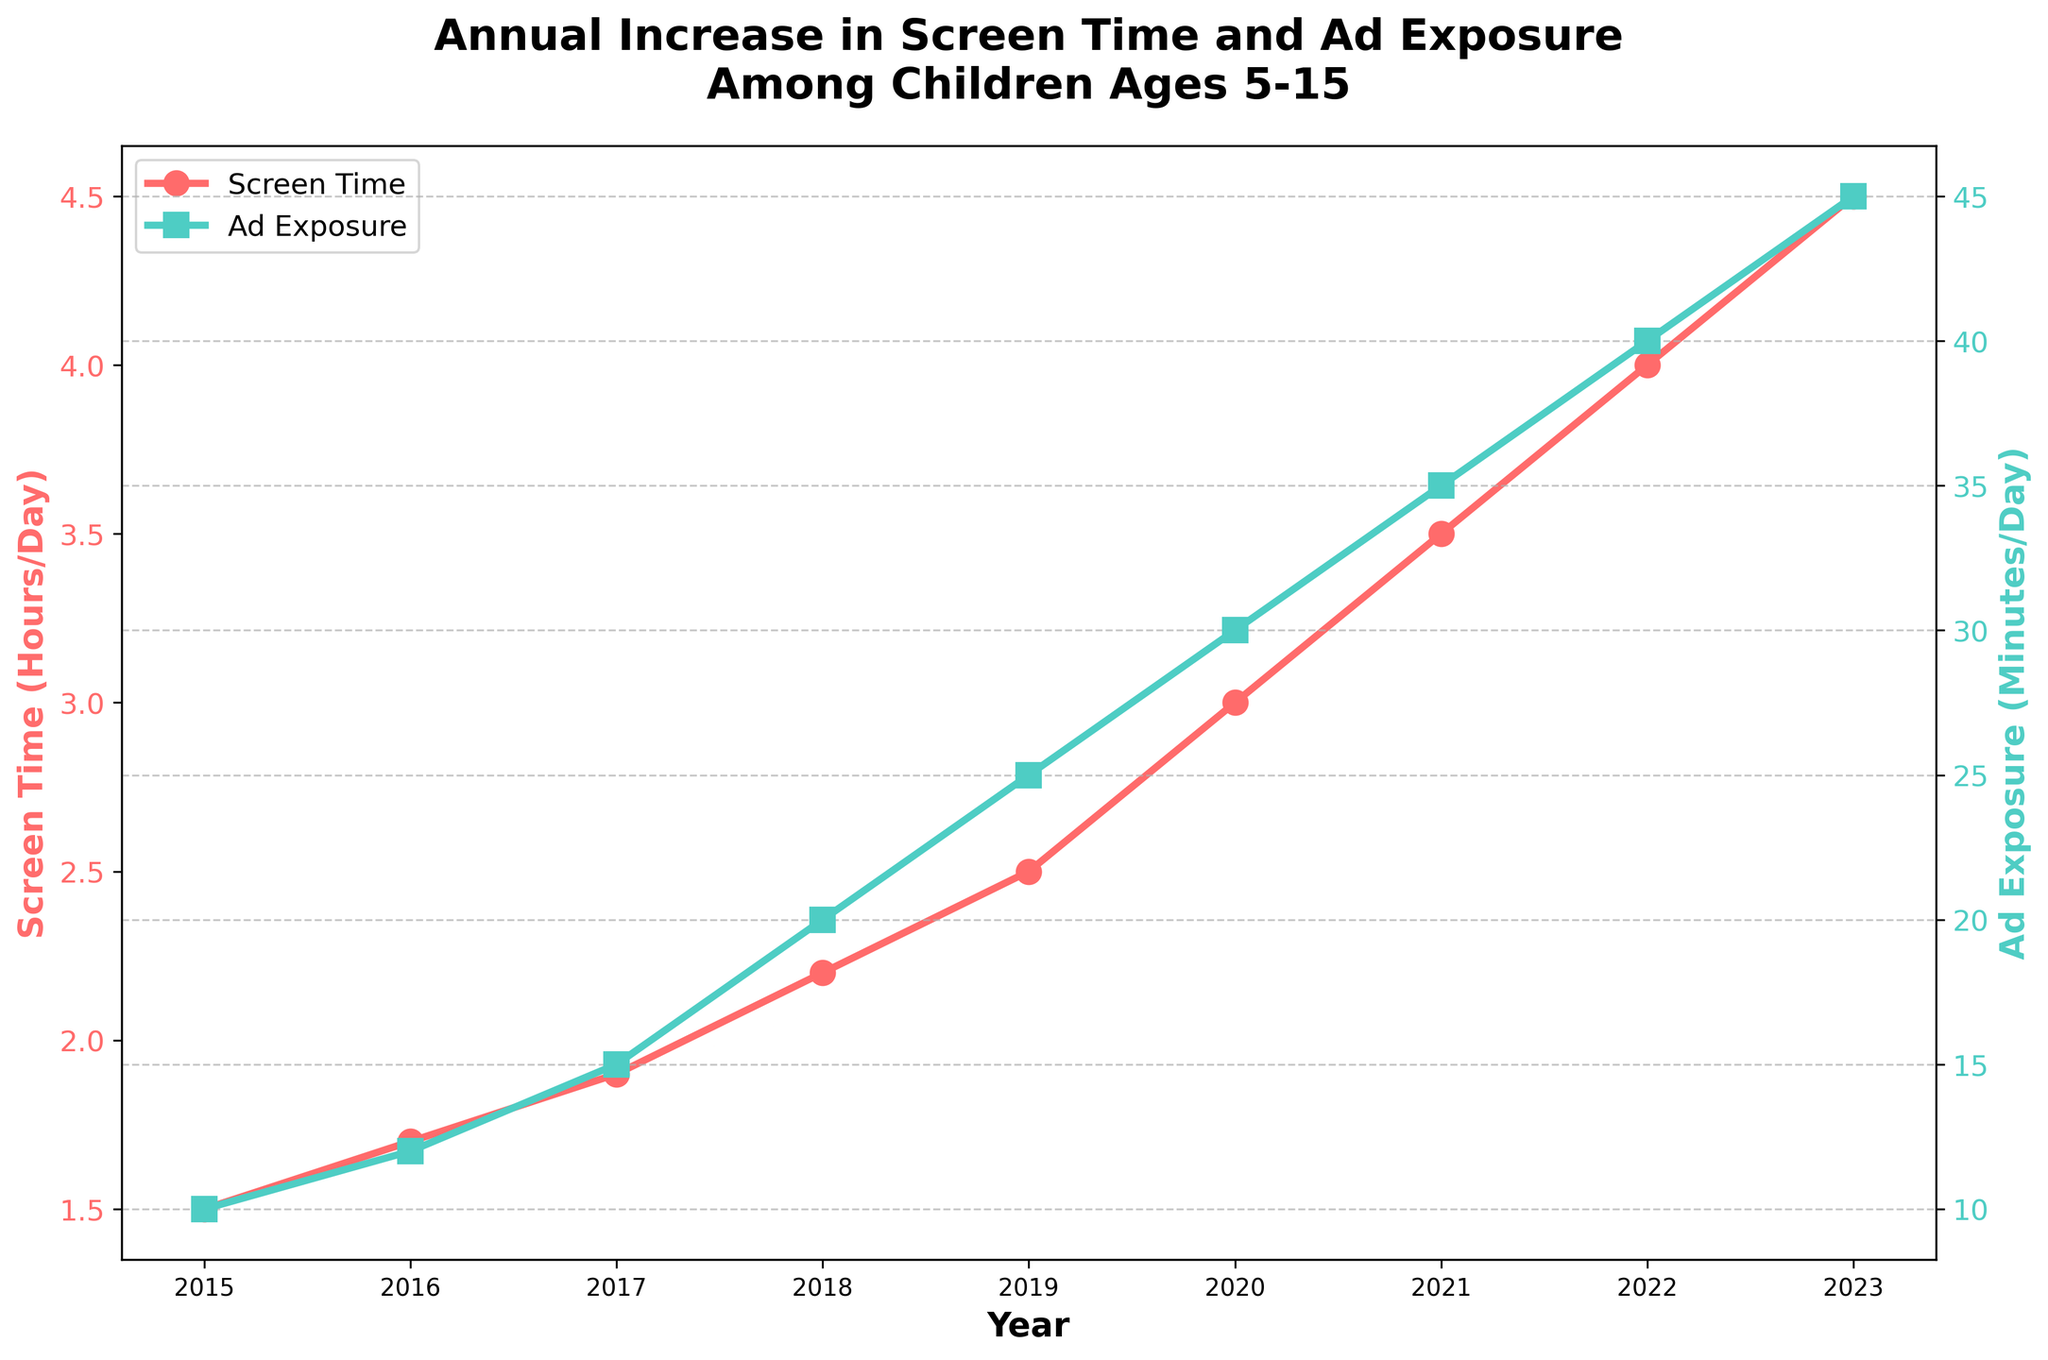What is the title of the plot? The title is typically placed above the graph and is usually the largest text. Here, it reads 'Annual Increase in Screen Time and Ad Exposure Among Children Ages 5-15'.
Answer: Annual Increase in Screen Time and Ad Exposure Among Children Ages 5-15 How many data points are plotted for each line? The x-axis spans from 2015 to 2023, and each year has a corresponding point on both the screen time and advertisement exposure lines. Counting these, there are 9 data points for each.
Answer: 9 What was the screen time in 2020? Look at the screen time line (red with circles) and identify the value for the year 2020. The y-axis value answers this question.
Answer: 3.0 hours/day In which year did children have the highest ad exposure? Find the highest point on the ad exposure line (blue with squares), then look down to the corresponding year on the x-axis.
Answer: 2023 How much did the ad exposure increase from 2015 to 2023? Look at the ad exposure values for 2015 (10 minutes/day) and 2023 (45 minutes/day). Subtract the initial value (10) from the final value (45).
Answer: 35 minutes/day What is the difference in screen time between 2018 and 2022? Identify the screen time for 2018 (2.2 hours/day) and 2022 (4.0 hours/day). Subtract the 2018 value from the 2022 value.
Answer: 1.8 hours/day By how many hours did screen time increase from 2016 to 2017? Find the screen time values for 2016 (1.7 hours/day) and 2017 (1.9 hours/day). Subtract the 2016 value from the 2017 value.
Answer: 0.2 hours/day What is the average ad exposure from 2015 to 2023? Sum up the ad exposure values from each year: 10 + 12 + 15 + 20 + 25 + 30 + 35 + 40 + 45 = 232. Then divide by the number of years (9).
Answer: 25.8 minutes/day What is the trend of screen time from 2015 to 2023? Observe the overall direction of the screen time line from 2015 through 2023. The line consistently moves upwards.
Answer: Increasing How does the increase in screen time compare to the increase in ad exposure over the period? Calculate the total increase for both metrics: Screen time increased from 1.5 to 4.5 hours/day (an increase of 3 hours/day). Ad exposure increased from 10 to 45 minutes/day (an increase of 35 minutes/day). Both increased, but ad exposure shows a larger relative increase.
Answer: Both increased; ad exposure had a larger relative increase 